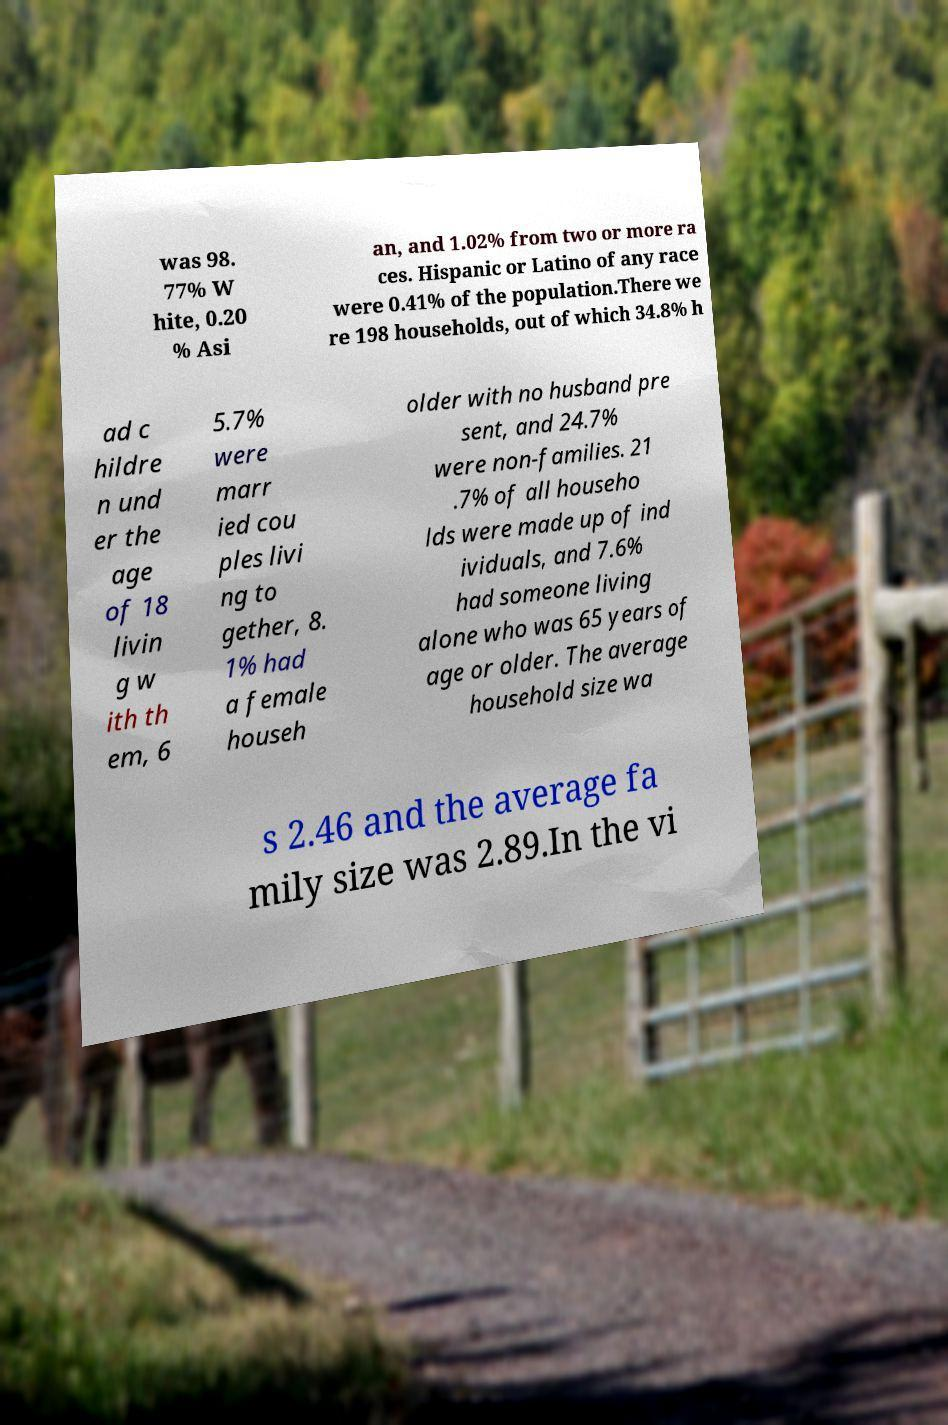For documentation purposes, I need the text within this image transcribed. Could you provide that? was 98. 77% W hite, 0.20 % Asi an, and 1.02% from two or more ra ces. Hispanic or Latino of any race were 0.41% of the population.There we re 198 households, out of which 34.8% h ad c hildre n und er the age of 18 livin g w ith th em, 6 5.7% were marr ied cou ples livi ng to gether, 8. 1% had a female househ older with no husband pre sent, and 24.7% were non-families. 21 .7% of all househo lds were made up of ind ividuals, and 7.6% had someone living alone who was 65 years of age or older. The average household size wa s 2.46 and the average fa mily size was 2.89.In the vi 